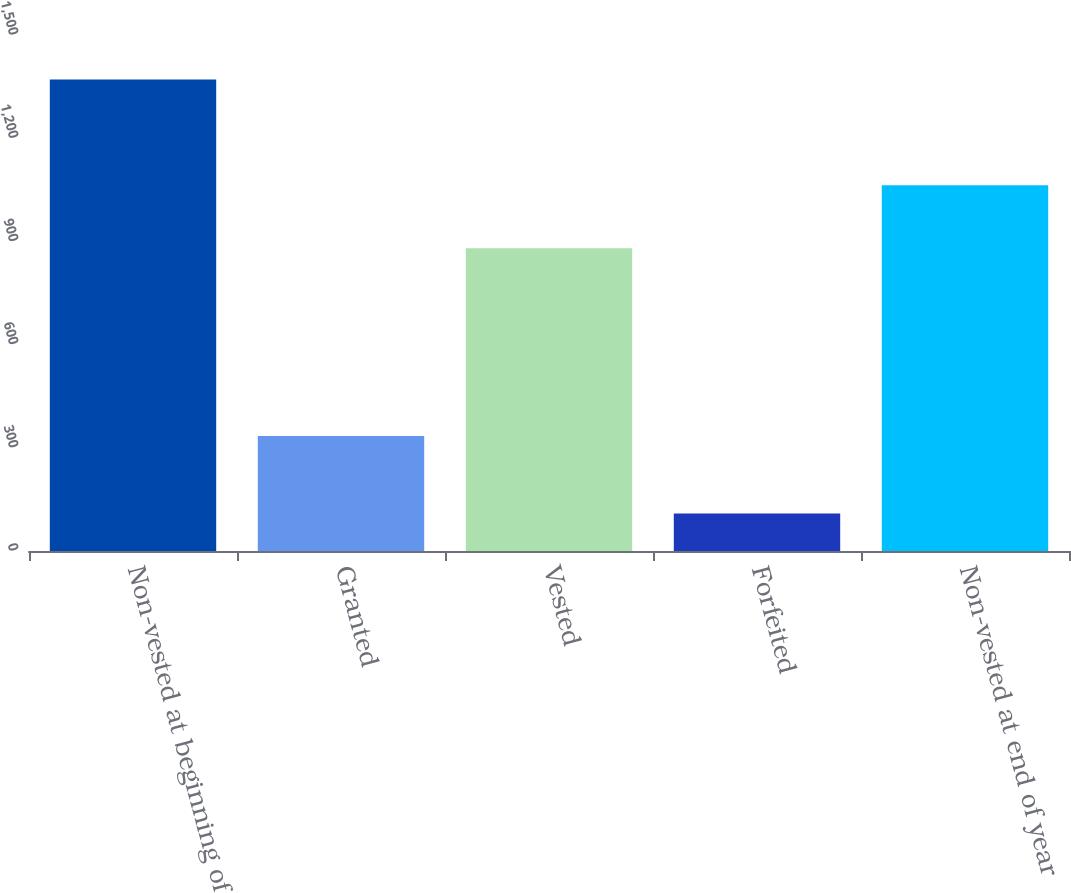Convert chart to OTSL. <chart><loc_0><loc_0><loc_500><loc_500><bar_chart><fcel>Non-vested at beginning of<fcel>Granted<fcel>Vested<fcel>Forfeited<fcel>Non-vested at end of year<nl><fcel>1371<fcel>334<fcel>880<fcel>109<fcel>1063<nl></chart> 